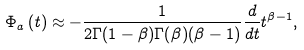<formula> <loc_0><loc_0><loc_500><loc_500>\Phi _ { a } \left ( t \right ) \approx - \frac { 1 } { 2 \Gamma ( 1 - \beta ) \Gamma ( \beta ) ( \beta - 1 ) } \frac { d } { d t } t ^ { \beta - 1 } ,</formula> 